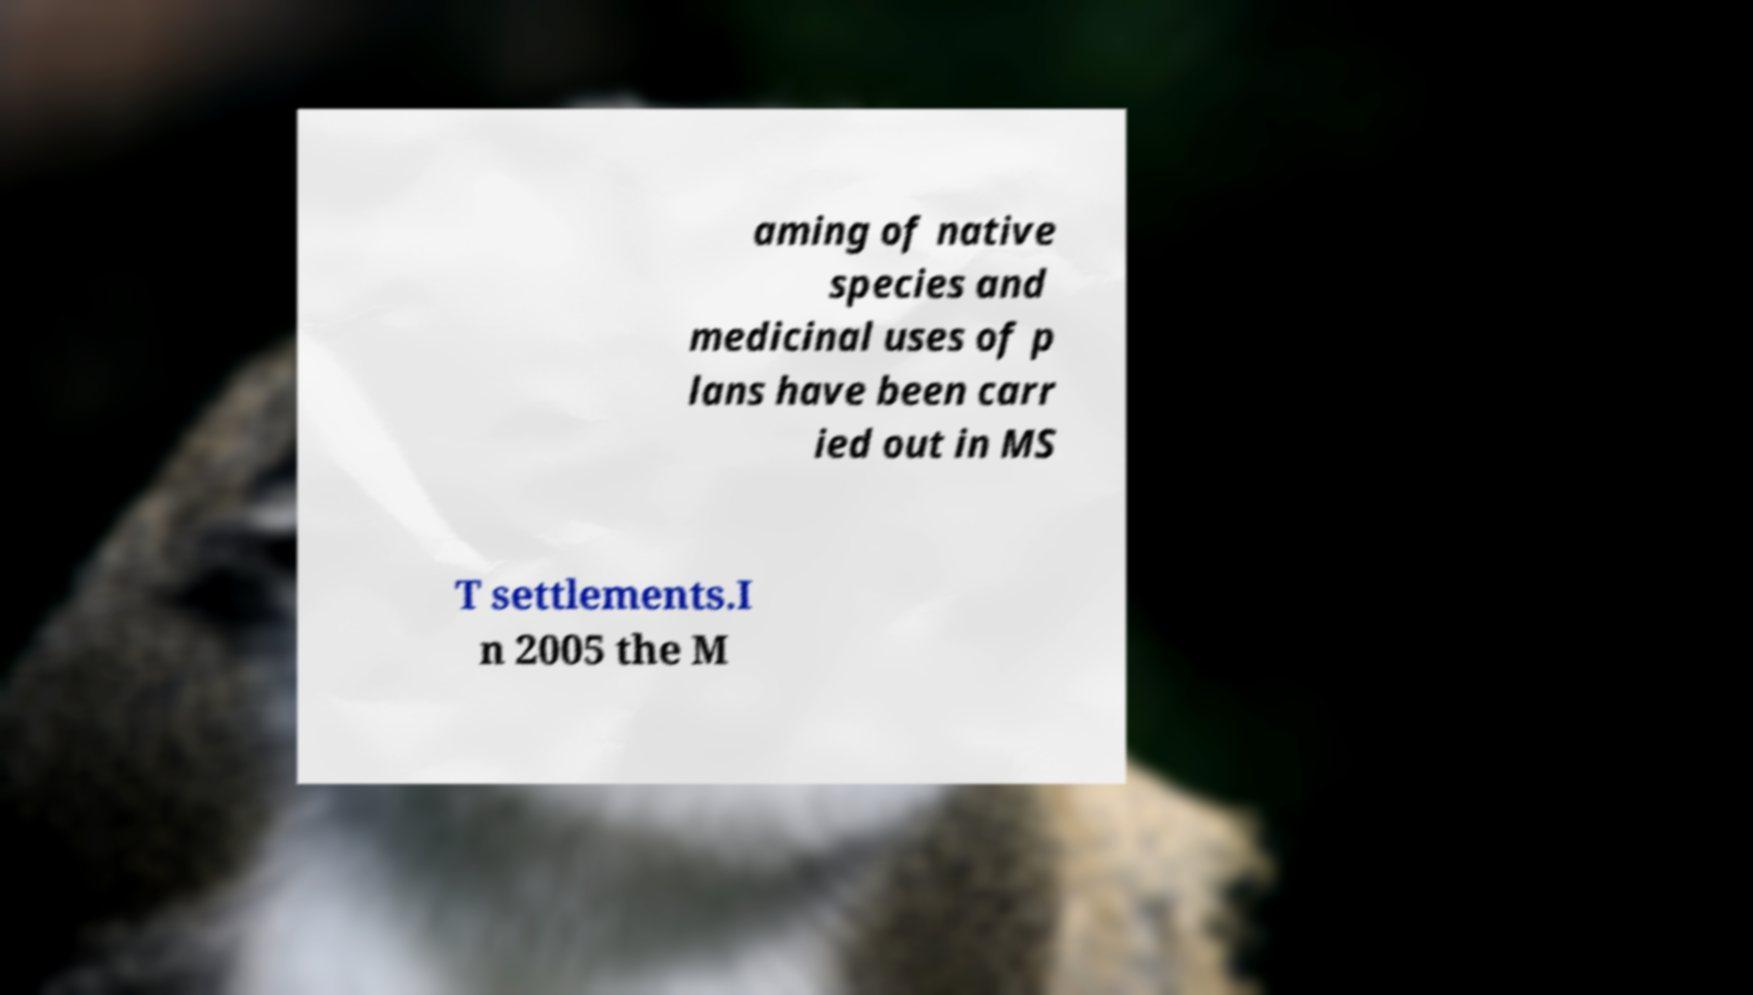Please read and relay the text visible in this image. What does it say? aming of native species and medicinal uses of p lans have been carr ied out in MS T settlements.I n 2005 the M 